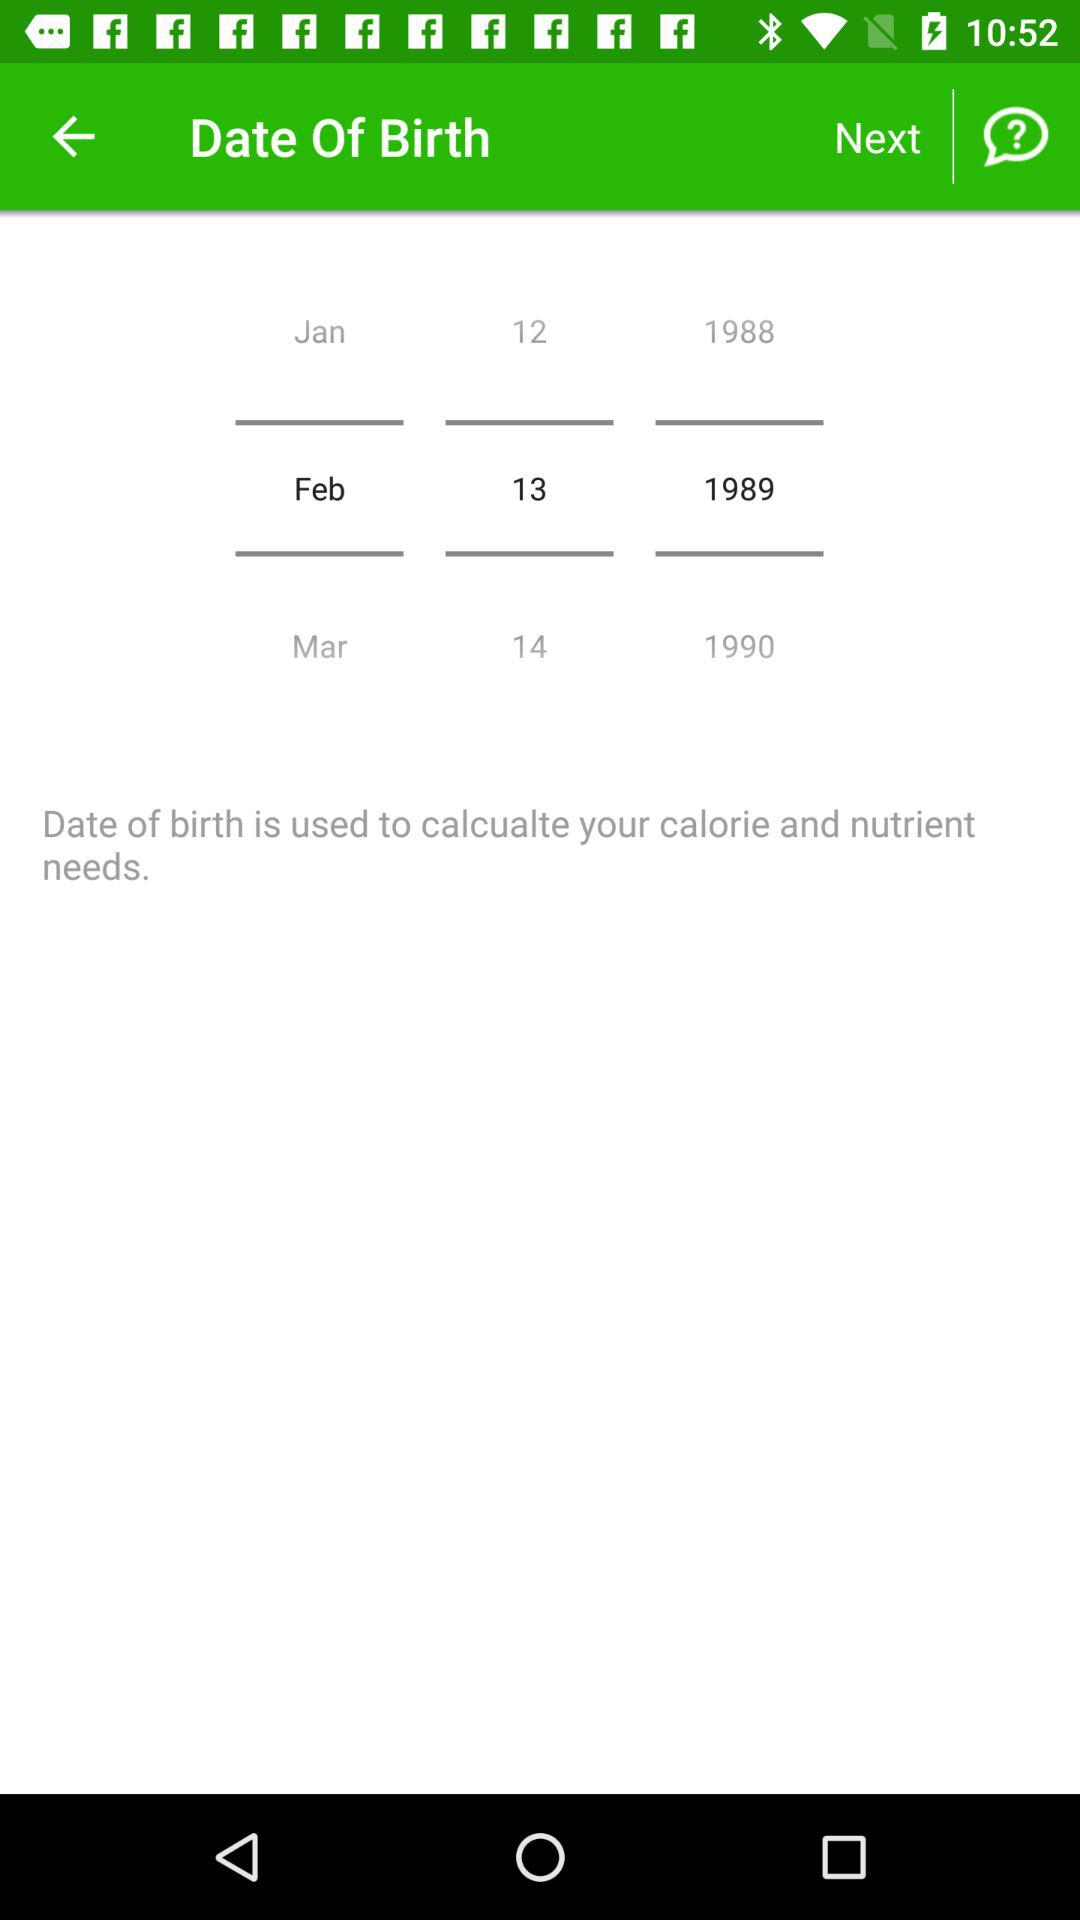What is the date of birth? The date of birth is February 13, 1989. 